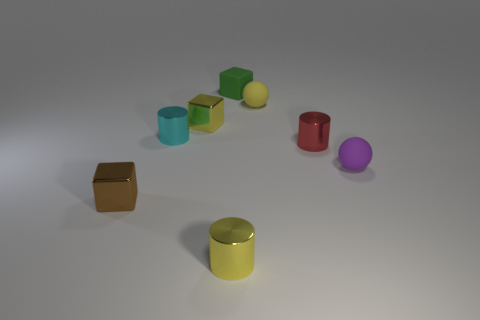Is there anything else of the same color as the small matte block? Upon reviewing the image, it appears that there are no other objects with the exact same shade as the small matte block. Each object in the scene has a unique color, emphasizing their individuality in this simple yet visually engaging arrangement. 